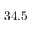Convert formula to latex. <formula><loc_0><loc_0><loc_500><loc_500>3 4 . 5</formula> 